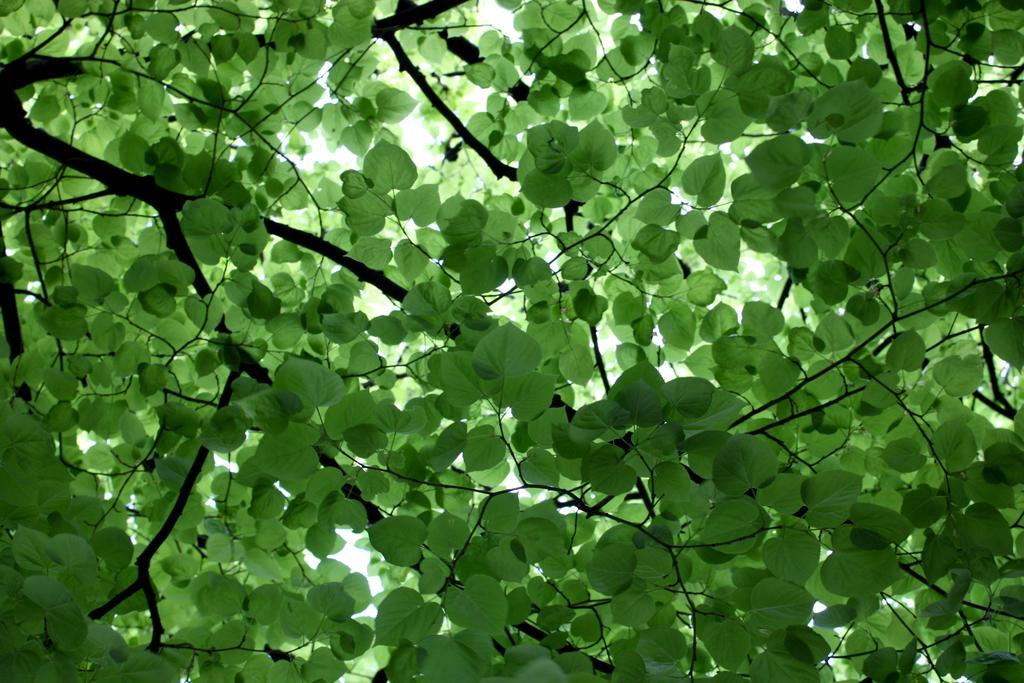Please provide a concise description of this image. In this picture we can see many green leaves and branches of a tree. 